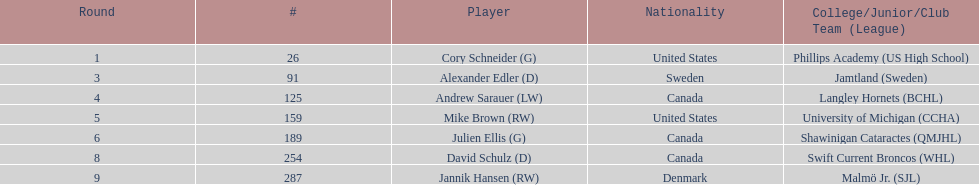What is the count of players who were from the united states? 2. Parse the table in full. {'header': ['Round', '#', 'Player', 'Nationality', 'College/Junior/Club Team (League)'], 'rows': [['1', '26', 'Cory Schneider (G)', 'United States', 'Phillips Academy (US High School)'], ['3', '91', 'Alexander Edler (D)', 'Sweden', 'Jamtland (Sweden)'], ['4', '125', 'Andrew Sarauer (LW)', 'Canada', 'Langley Hornets (BCHL)'], ['5', '159', 'Mike Brown (RW)', 'United States', 'University of Michigan (CCHA)'], ['6', '189', 'Julien Ellis (G)', 'Canada', 'Shawinigan Cataractes (QMJHL)'], ['8', '254', 'David Schulz (D)', 'Canada', 'Swift Current Broncos (WHL)'], ['9', '287', 'Jannik Hansen (RW)', 'Denmark', 'Malmö Jr. (SJL)']]} 